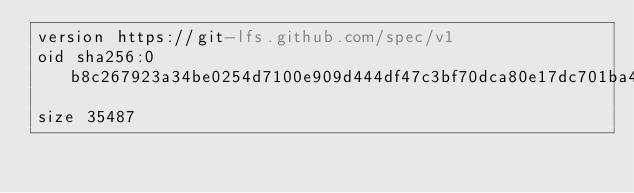Convert code to text. <code><loc_0><loc_0><loc_500><loc_500><_YAML_>version https://git-lfs.github.com/spec/v1
oid sha256:0b8c267923a34be0254d7100e909d444df47c3bf70dca80e17dc701ba44f6401
size 35487
</code> 